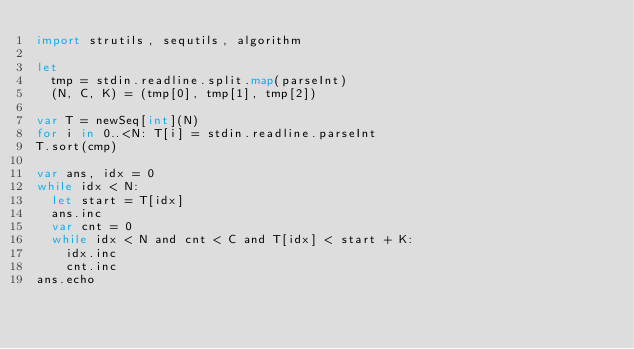Convert code to text. <code><loc_0><loc_0><loc_500><loc_500><_Nim_>import strutils, sequtils, algorithm

let
  tmp = stdin.readline.split.map(parseInt)
  (N, C, K) = (tmp[0], tmp[1], tmp[2])

var T = newSeq[int](N)
for i in 0..<N: T[i] = stdin.readline.parseInt
T.sort(cmp)

var ans, idx = 0
while idx < N:
  let start = T[idx]
  ans.inc
  var cnt = 0
  while idx < N and cnt < C and T[idx] < start + K:
    idx.inc
    cnt.inc
ans.echo
</code> 